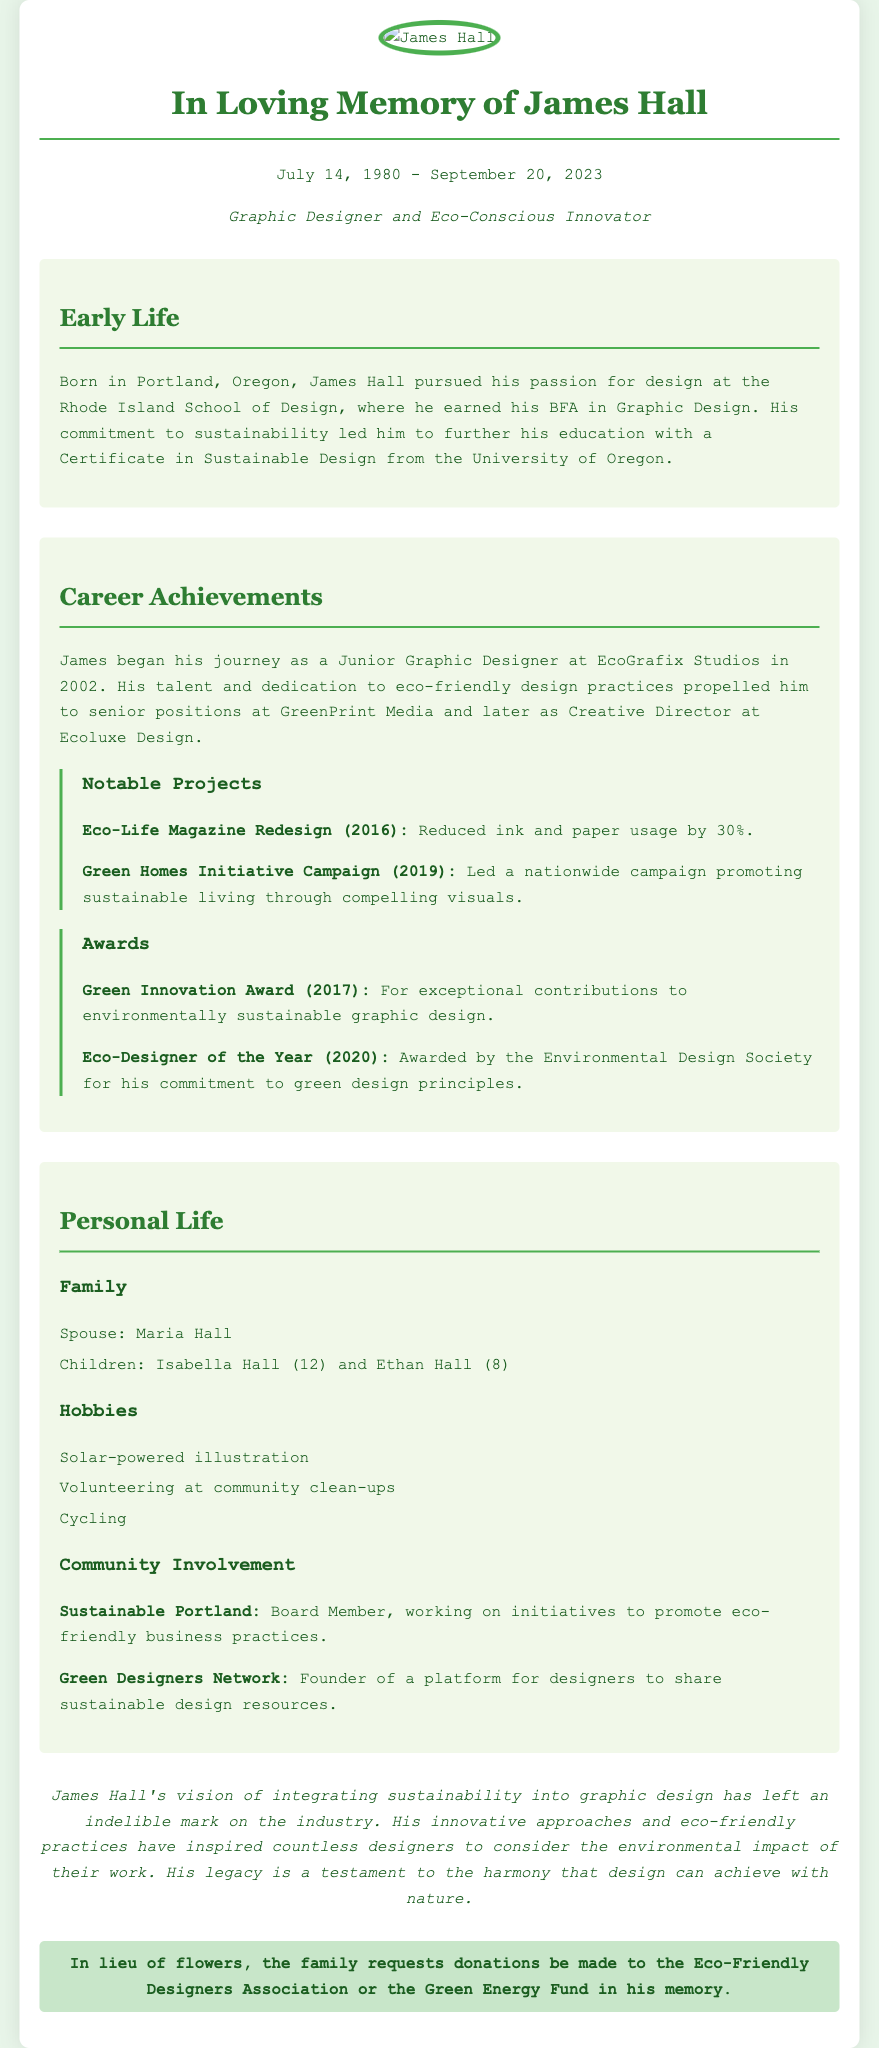What is James Hall's birth date? The document states that James Hall was born on July 14, 1980.
Answer: July 14, 1980 Where did James Hall earn his BFA? The document mentions that he earned his BFA in Graphic Design from the Rhode Island School of Design.
Answer: Rhode Island School of Design What is one notable project James worked on in 2016? The document lists "Eco-Life Magazine Redesign" as a notable project he worked on in 2016.
Answer: Eco-Life Magazine Redesign Who awarded James the Eco-Designer of the Year? The document states that he was awarded by the Environmental Design Society for his commitment to green design principles.
Answer: Environmental Design Society What are the names of James Hall's children? The document provides the names of his children as Isabella Hall and Ethan Hall.
Answer: Isabella Hall and Ethan Hall What initiative did James Hall lead in 2019? The document states that he led the "Green Homes Initiative Campaign" promoting sustainable living.
Answer: Green Homes Initiative Campaign What is a hobby of James Hall listed in the document? The document mentions "Solar-powered illustration" as one of his hobbies.
Answer: Solar-powered illustration What is a request made by the family in lieu of flowers? The document requests donations to be made to the Eco-Friendly Designers Association or the Green Energy Fund in his memory.
Answer: Donations to Eco-Friendly Designers Association or Green Energy Fund 